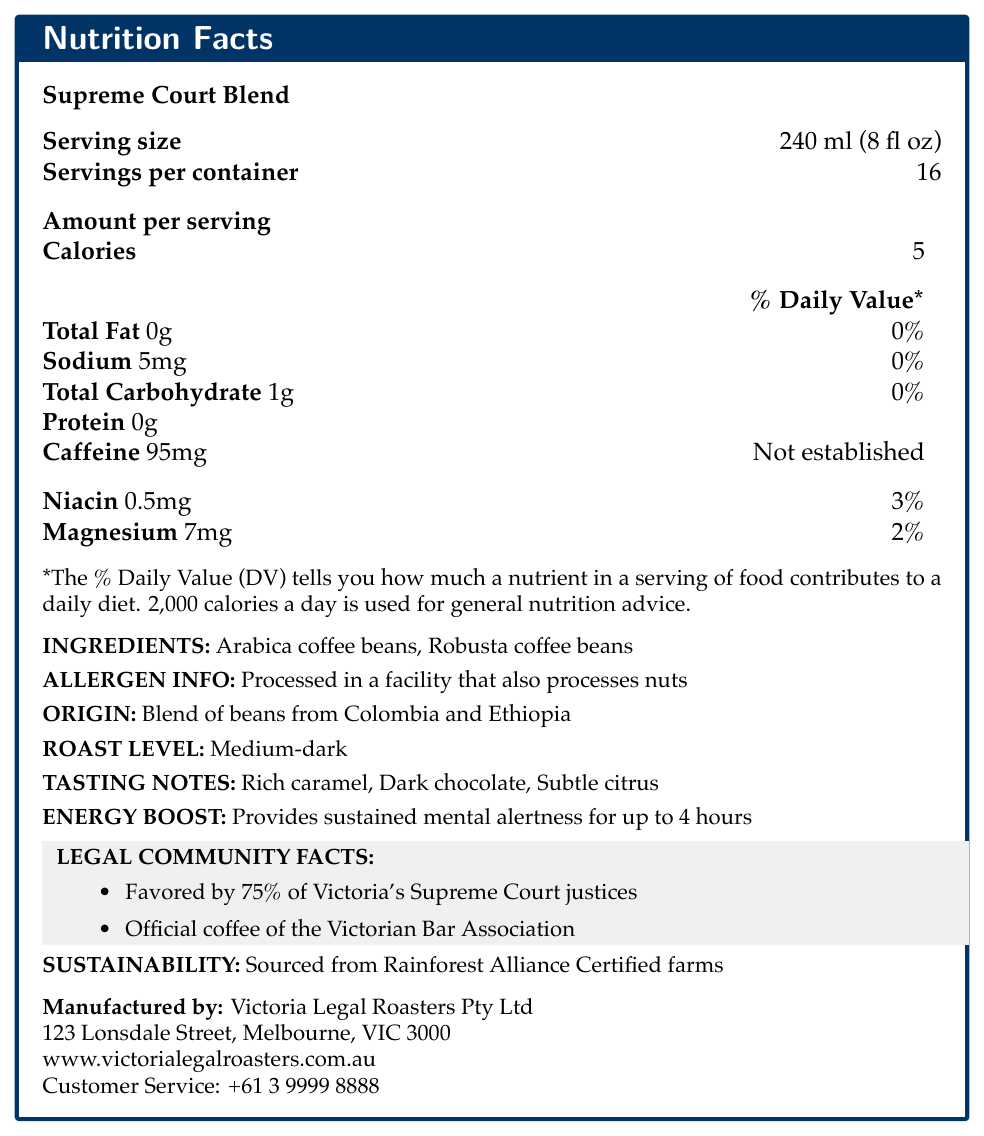what is the serving size of Supreme Court Blend? The document lists the serving size as 240 ml (8 fl oz).
Answer: 240 ml (8 fl oz) how many servings are there per container? The document states that there are 16 servings per container.
Answer: 16 how many calories are there in one serving? The document shows that each serving has 5 calories.
Answer: 5 what is the amount of caffeine per serving? The document indicates that each serving contains 95mg of caffeine.
Answer: 95mg what are the main ingredients in Supreme Court Blend? The ingredients listed in the document are Arabica coffee beans and Robusta coffee beans.
Answer: Arabica coffee beans, Robusta coffee beans how much sodium is there in one serving? The document specifies that each serving contains 5mg of sodium.
Answer: 5mg which vitamin and mineral are included in the nutritional information? The document mentions Niacin (0.5mg, 3% DV) and Magnesium (7mg, 2% DV).
Answer: Niacin and Magnesium what is the roast level of this coffee blend? The document indicates that the roast level is medium-dark.
Answer: Medium-dark how long does the energy boost from this coffee last? The document states that the energy boost provides sustained mental alertness for up to 4 hours.
Answer: Up to 4 hours where is Supreme Court Blend sourced from? The document notes that the coffee is a blend of beans from Colombia and Ethiopia.
Answer: Colombia and Ethiopia which of the following legal institutions favor the Supreme Court Blend? A. Federal Court B. Victoria's Supreme Court C. Magistrates’ Court The document states that Supreme Court Blend is favored by 75% of Victoria's Supreme Court justices.
Answer: B what percentage of Victoria's Supreme Court justices favor this blend? The document specifies that 75% of Victoria's Supreme Court justices favor this blend.
Answer: 75% what is the total carbohydrate content per serving? The document lists the total carbohydrate content per serving as 1g.
Answer: 1g is this coffee processed in a nut-free facility? The document mentions that the coffee is processed in a facility that also processes nuts.
Answer: No who manufactures the Supreme Court Blend? The document indicates that Victoria Legal Roasters Pty Ltd is the manufacturer.
Answer: Victoria Legal Roasters Pty Ltd what economic benefit does drinking this coffee provide? The document does not provide any financial or economic benefits related to drinking the coffee.
Answer: Not enough information describe the main idea of the document. The document provides comprehensive information about the Supreme Court Blend coffee, including serving size, calories, caffeine, vitamins, minerals, ingredients, allergen info, origin, roast level, tasting notes, and its popularity among Victoria's legal community.
Answer: The document is a nutrition facts label for Supreme Court Blend coffee by Victoria Legal Roasters Pty Ltd, detailing nutritional information, ingredients, origin, roast level, energy boost attributes, and its association with the legal community in Victoria. 